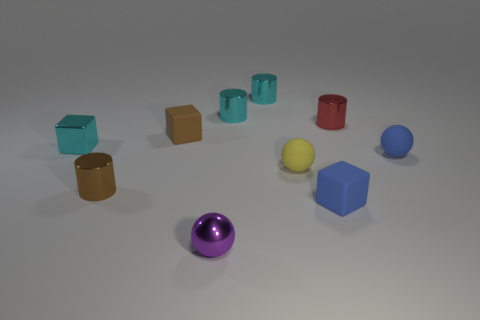What number of objects are yellow spheres that are in front of the red metal cylinder or small blue blocks?
Ensure brevity in your answer.  2. Do the small block in front of the blue sphere and the metal ball have the same color?
Provide a succinct answer. No. What number of other objects are the same color as the small shiny block?
Keep it short and to the point. 2. What number of big objects are either brown rubber objects or yellow rubber things?
Offer a terse response. 0. Is the number of red metal cylinders greater than the number of brown metallic blocks?
Provide a succinct answer. Yes. Is the material of the cyan block the same as the small yellow ball?
Give a very brief answer. No. Is there anything else that is the same material as the blue block?
Offer a very short reply. Yes. Are there more yellow matte balls that are on the left side of the tiny brown matte block than small red shiny objects?
Offer a terse response. No. Does the tiny shiny cube have the same color as the shiny ball?
Your response must be concise. No. How many blue rubber things are the same shape as the small purple metallic object?
Give a very brief answer. 1. 